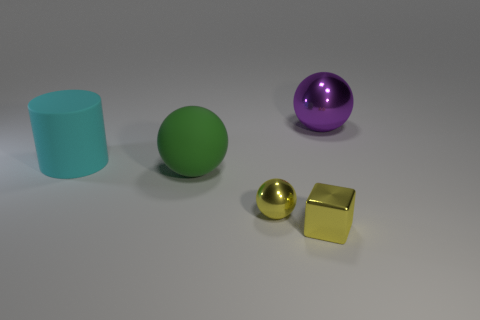The green matte object that is the same size as the purple shiny sphere is what shape?
Offer a terse response. Sphere. Is there a large green object of the same shape as the cyan thing?
Offer a very short reply. No. What is the material of the green thing?
Give a very brief answer. Rubber. There is a cylinder; are there any shiny spheres in front of it?
Ensure brevity in your answer.  Yes. There is a large ball in front of the purple thing; how many metal spheres are behind it?
Provide a short and direct response. 1. There is a green object that is the same size as the cyan thing; what material is it?
Provide a succinct answer. Rubber. What number of other things are the same material as the purple thing?
Your answer should be compact. 2. There is a large purple sphere; how many big purple metallic balls are behind it?
Offer a very short reply. 0. What number of spheres are purple objects or small yellow objects?
Your answer should be compact. 2. What size is the ball that is both to the right of the big green ball and in front of the purple thing?
Provide a succinct answer. Small. 